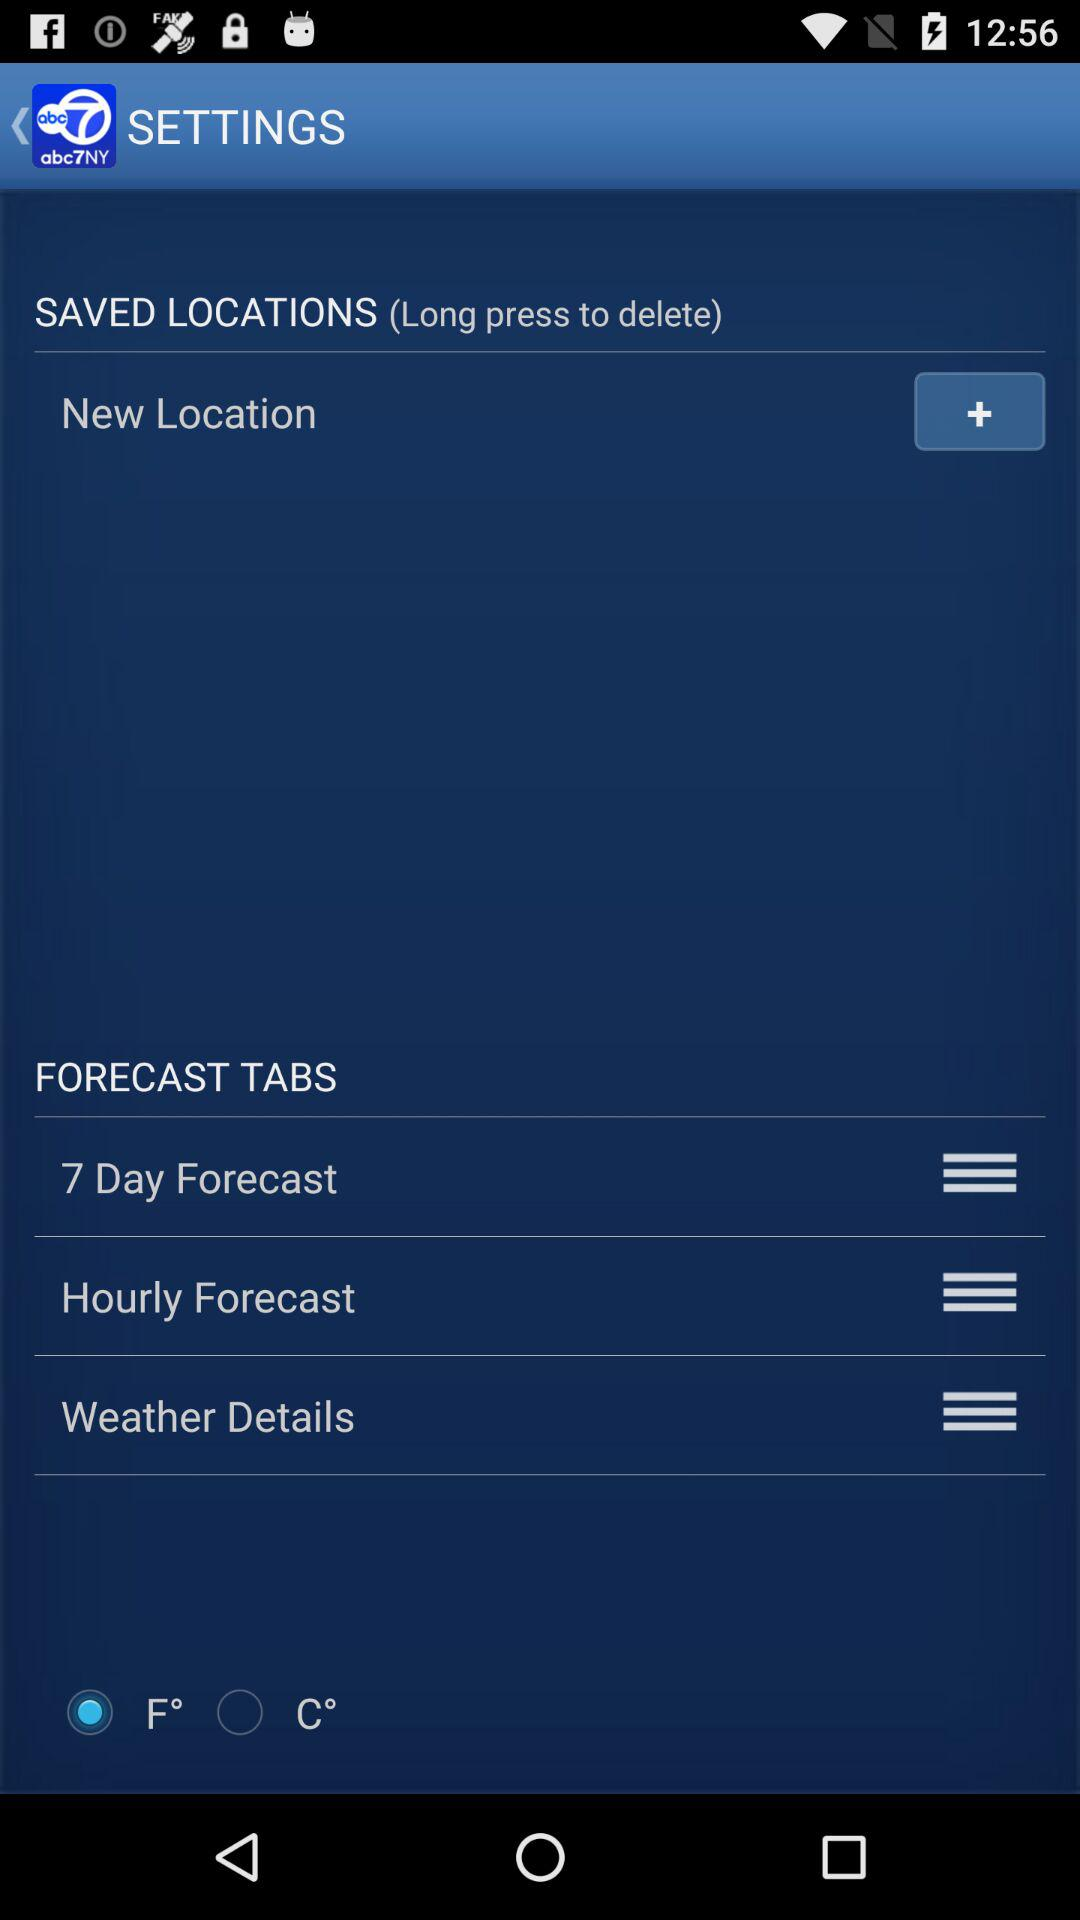What are the different categories in "FORECAST TABS"? The different categories in "FORECAST TABS" are "7 Days Forecast", "Hourly Forecast" and "Weather Details". 